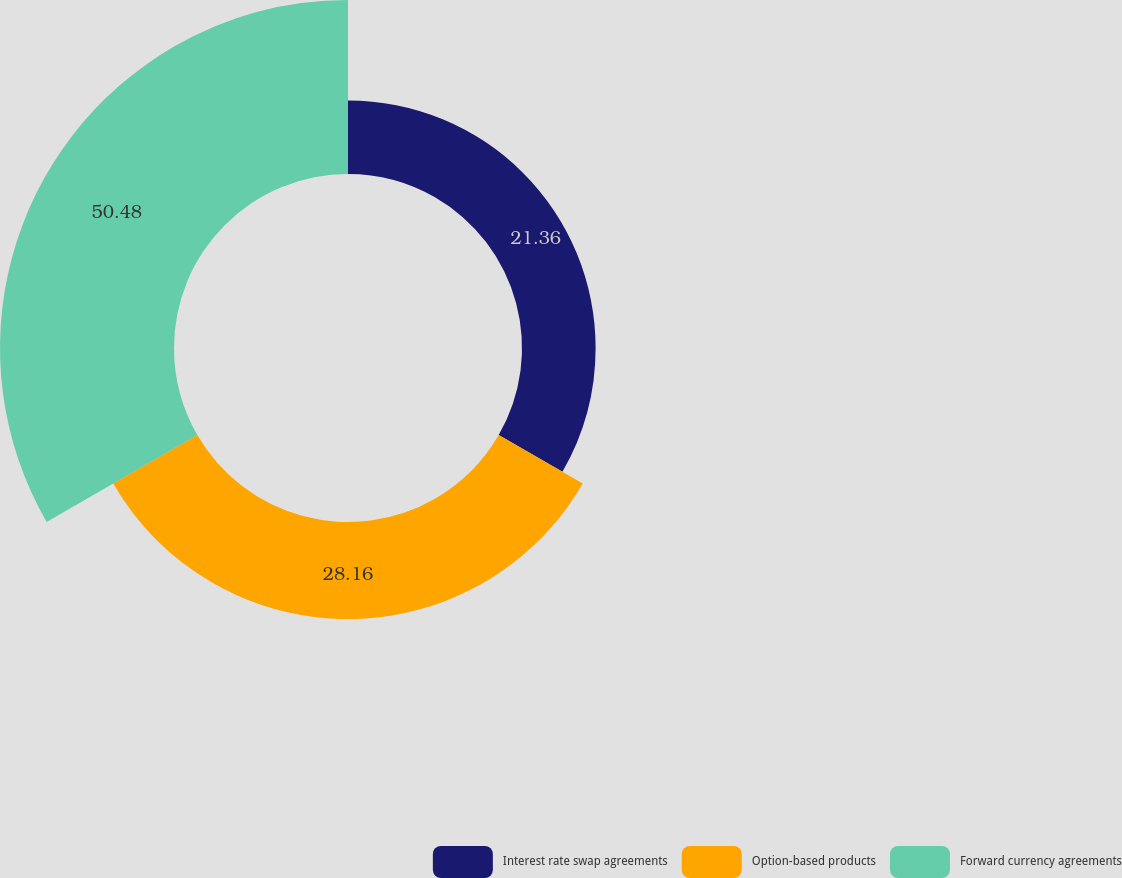<chart> <loc_0><loc_0><loc_500><loc_500><pie_chart><fcel>Interest rate swap agreements<fcel>Option-based products<fcel>Forward currency agreements<nl><fcel>21.36%<fcel>28.16%<fcel>50.49%<nl></chart> 